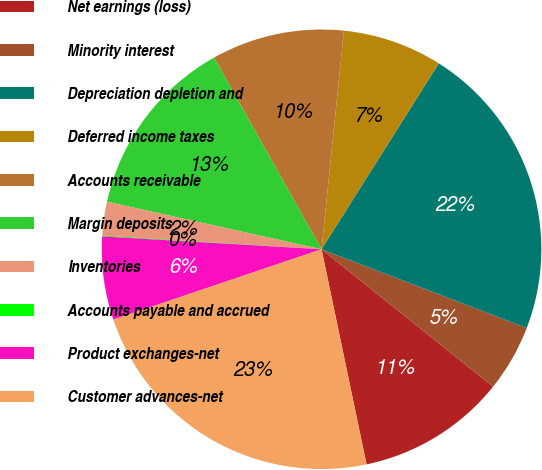<chart> <loc_0><loc_0><loc_500><loc_500><pie_chart><fcel>Net earnings (loss)<fcel>Minority interest<fcel>Depreciation depletion and<fcel>Deferred income taxes<fcel>Accounts receivable<fcel>Margin deposits<fcel>Inventories<fcel>Accounts payable and accrued<fcel>Product exchanges-net<fcel>Customer advances-net<nl><fcel>10.97%<fcel>4.91%<fcel>21.88%<fcel>7.33%<fcel>9.76%<fcel>13.39%<fcel>2.48%<fcel>0.06%<fcel>6.12%<fcel>23.09%<nl></chart> 